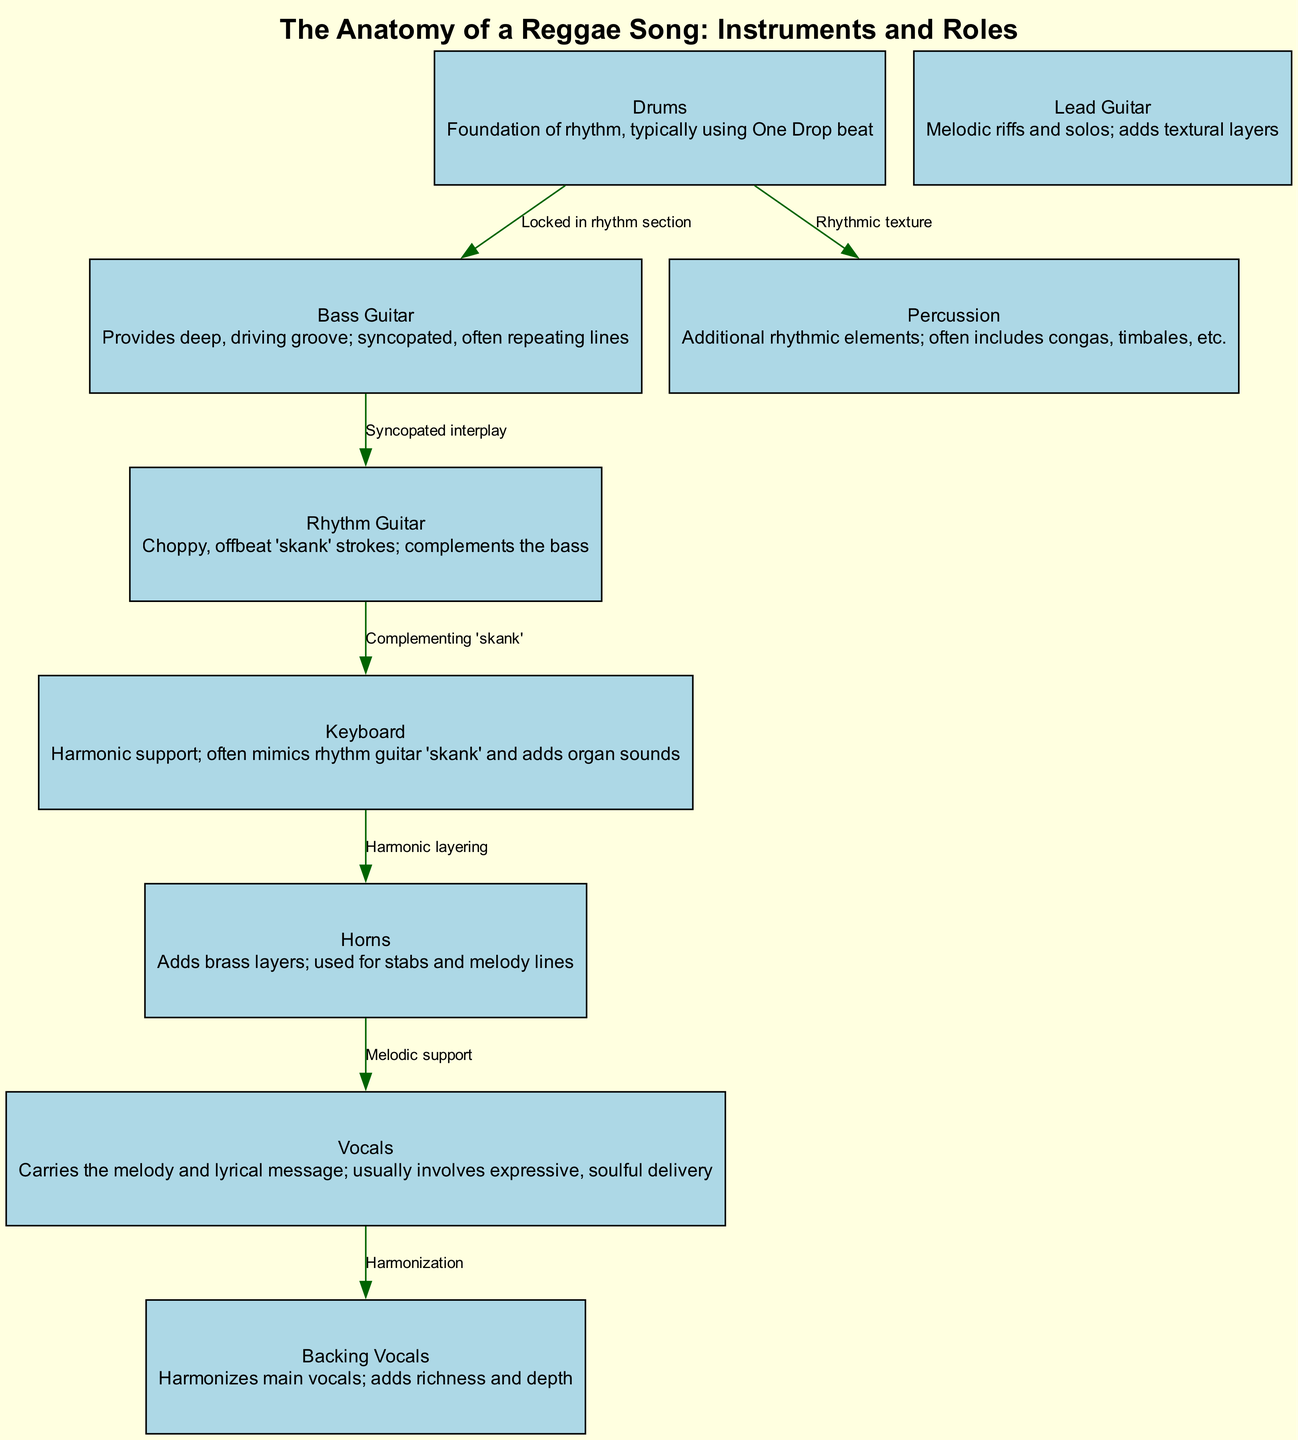What is the primary function of the drums in reggae music? The diagram describes the drums as the "Foundation of rhythm" and indicates that they typically use the "One Drop beat." This highlights their role in establishing the backbone rhythm of a reggae song.
Answer: Foundation of rhythm, typically using One Drop beat How many nodes are present in the diagram? The diagram contains a total of 9 nodes, representing different instruments and roles involved in reggae music. This includes drums, bass guitar, rhythm guitar, lead guitar, keyboard, horns, percussion, vocals, and backing vocals.
Answer: 9 What connects the rhythm guitar and the keyboard? The relationship described in the diagram indicates that the rhythm guitar complements the keyboard through the "Complementing 'skank'" label. This shows the interaction between the two instruments in creating the reggae sound.
Answer: Complementing 'skank' Which instrument is responsible for adding melodic support? According to the diagram, the horns are identified as the instrument that "Adds brass layers" and provides "Melodic support," making them crucial for enriching the music's texture.
Answer: Horns What role do backing vocals play in relation to the main vocals? The diagram illustrates that backing vocals "Harmonize main vocals," indicating that their role is to provide additional harmony and depth to the primary vocal line.
Answer: Harmonization 